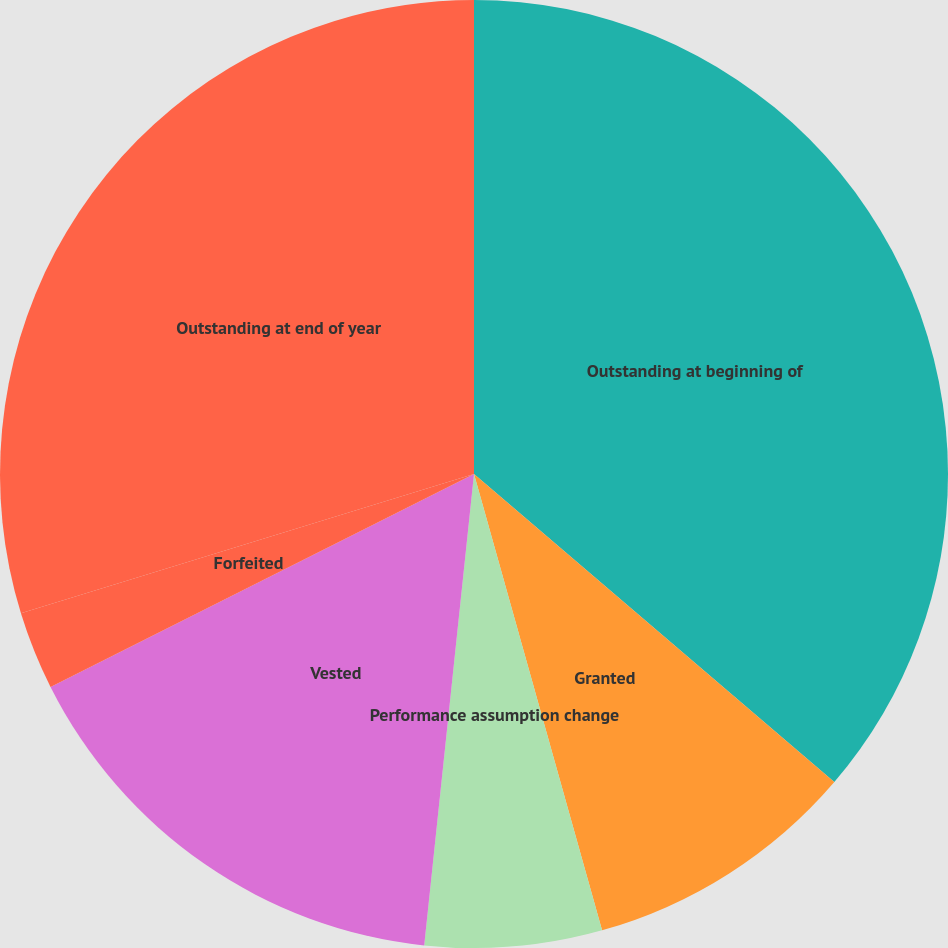Convert chart. <chart><loc_0><loc_0><loc_500><loc_500><pie_chart><fcel>Outstanding at beginning of<fcel>Granted<fcel>Performance assumption change<fcel>Vested<fcel>Forfeited<fcel>Outstanding at end of year<nl><fcel>36.26%<fcel>9.39%<fcel>6.03%<fcel>15.91%<fcel>2.67%<fcel>29.75%<nl></chart> 